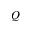Convert formula to latex. <formula><loc_0><loc_0><loc_500><loc_500>Q</formula> 